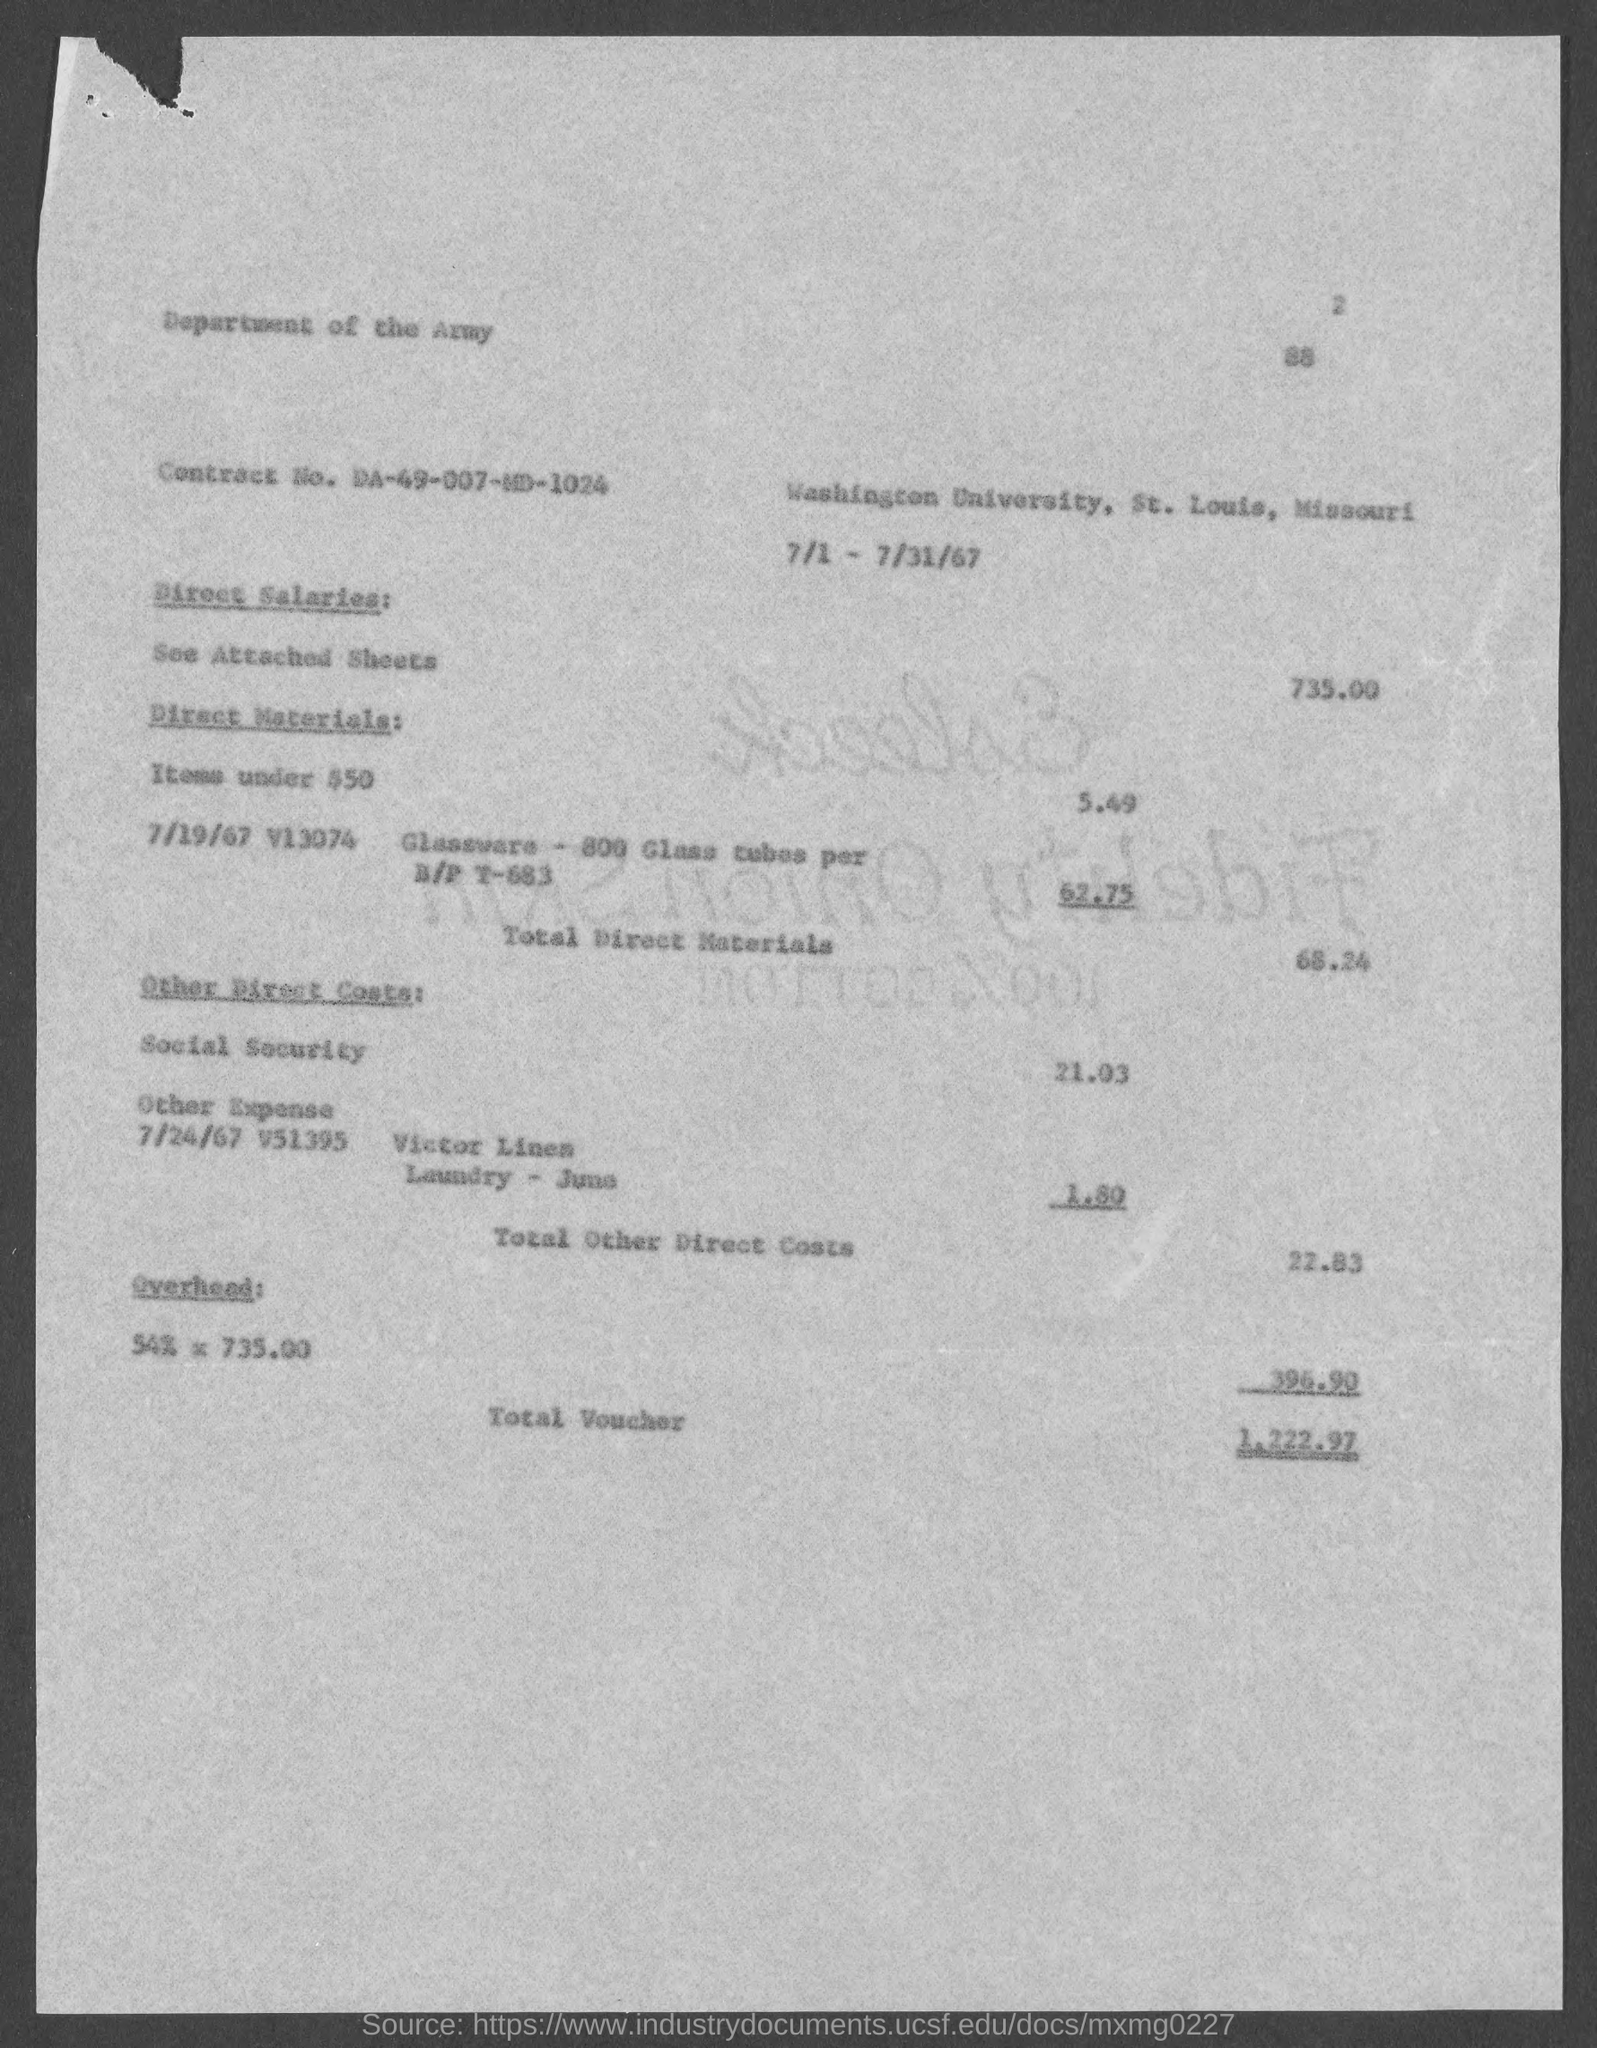What is the total voucher amount mentioned in the document?
 1,222.97 